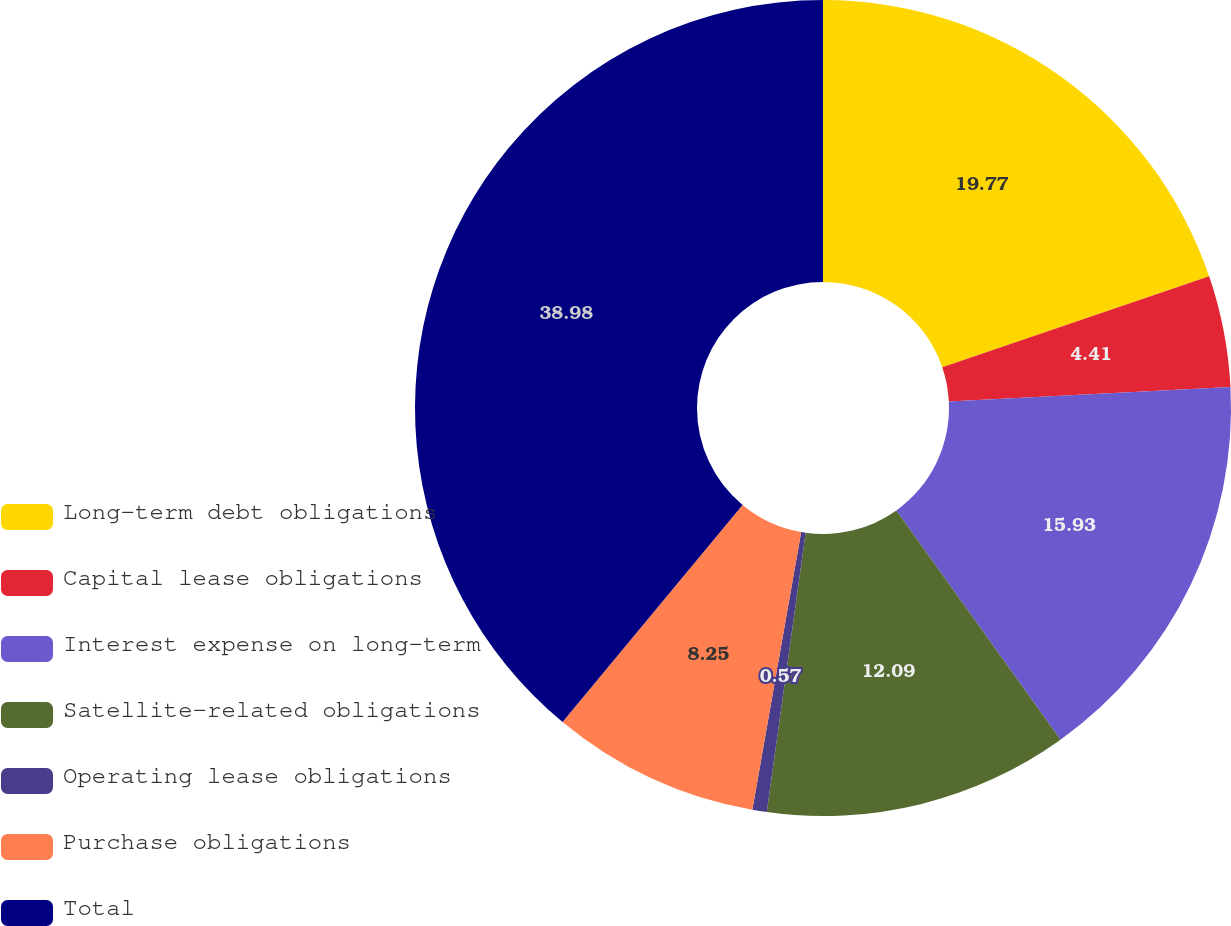Convert chart. <chart><loc_0><loc_0><loc_500><loc_500><pie_chart><fcel>Long-term debt obligations<fcel>Capital lease obligations<fcel>Interest expense on long-term<fcel>Satellite-related obligations<fcel>Operating lease obligations<fcel>Purchase obligations<fcel>Total<nl><fcel>19.77%<fcel>4.41%<fcel>15.93%<fcel>12.09%<fcel>0.57%<fcel>8.25%<fcel>38.98%<nl></chart> 